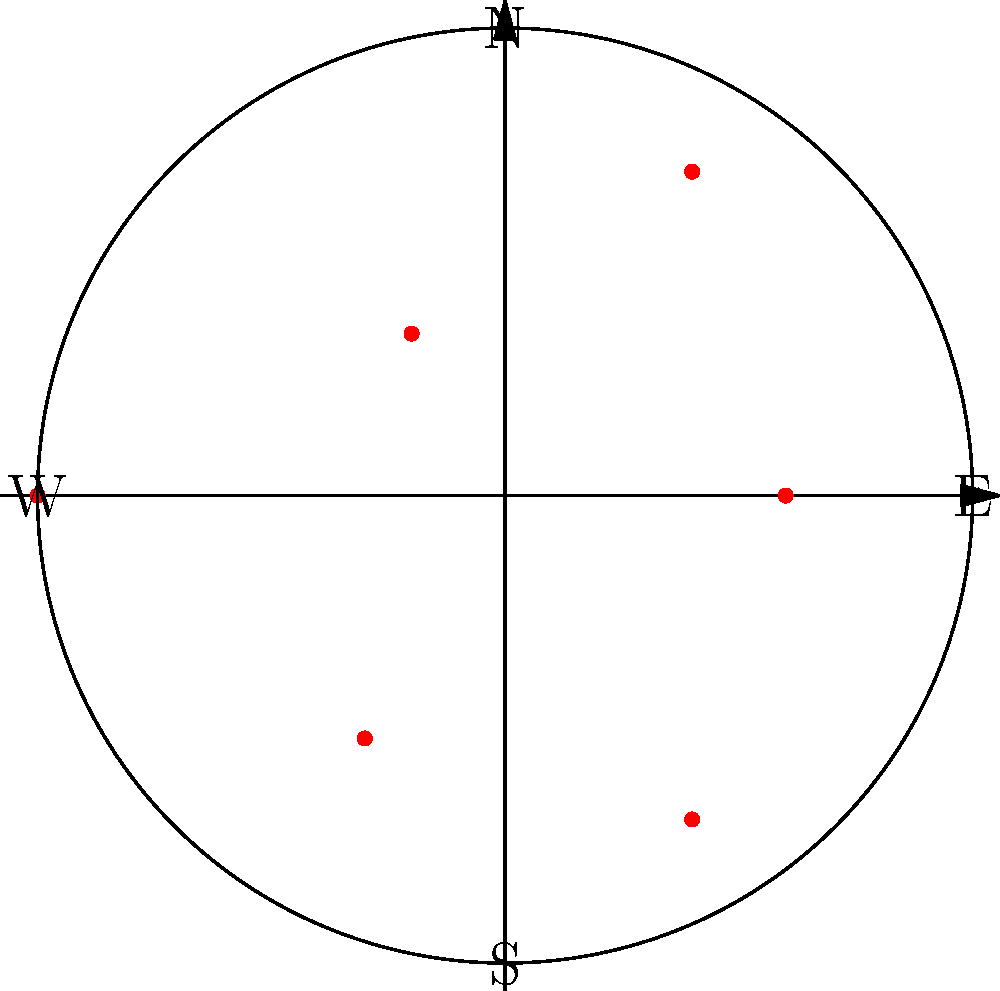In a circular refugee camp with a radius of 5 km, six water access points are distributed as shown in the polar coordinate system. The radial distances (in km) from the center and angular positions (in radians) of these points are:
$$(3, 0), (4, \frac{\pi}{3}), (2, \frac{2\pi}{3}), (5, \pi), (3, \frac{4\pi}{3}), (4, \frac{5\pi}{3})$$
What is the average distance of these water access points from the center of the camp? To find the average distance of the water access points from the center of the camp, we need to:

1. List all the radial distances:
   $3, 4, 2, 5, 3, 4$ km

2. Calculate the sum of these distances:
   $3 + 4 + 2 + 5 + 3 + 4 = 21$ km

3. Count the total number of water access points:
   There are 6 points.

4. Calculate the average by dividing the sum by the number of points:
   $\frac{21}{6} = 3.5$ km

Therefore, the average distance of the water access points from the center of the camp is 3.5 km.
Answer: 3.5 km 